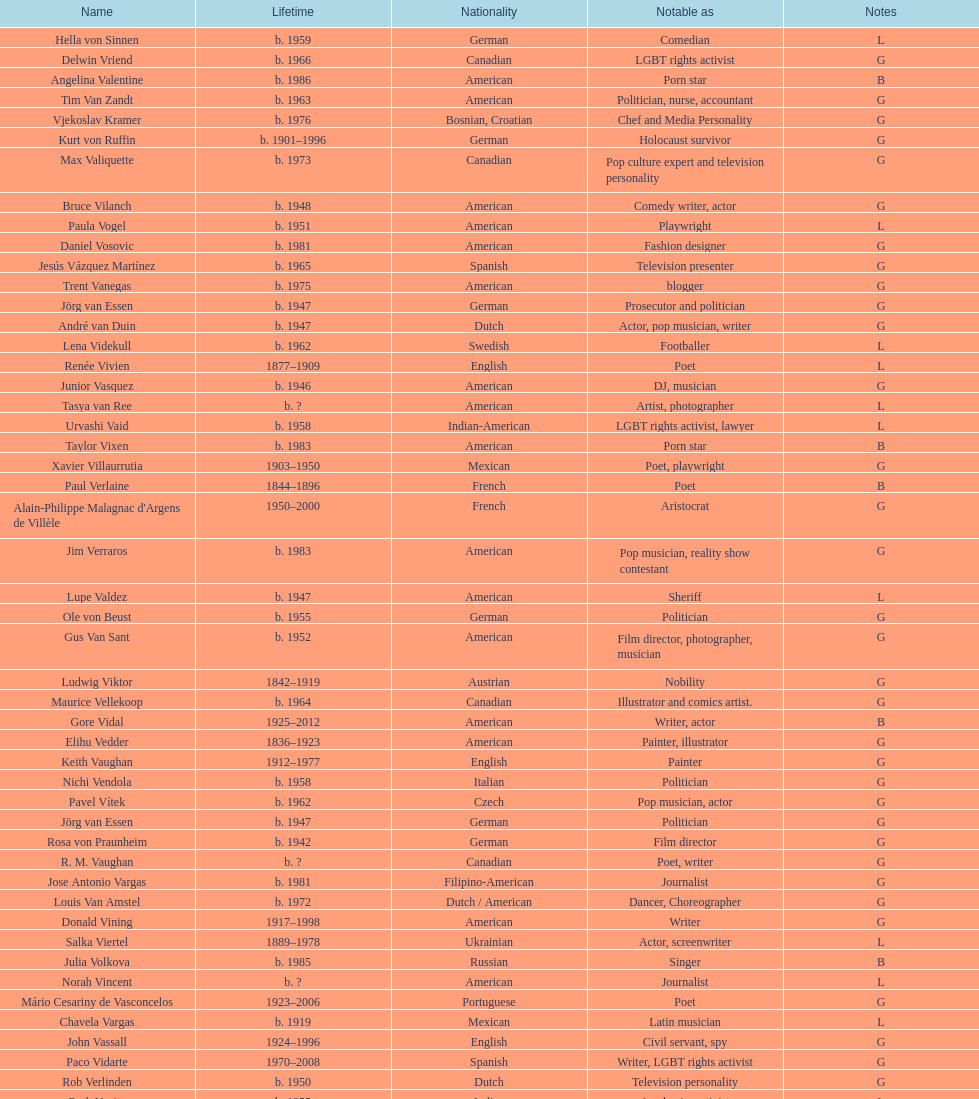Help me parse the entirety of this table. {'header': ['Name', 'Lifetime', 'Nationality', 'Notable as', 'Notes'], 'rows': [['Hella von Sinnen', 'b. 1959', 'German', 'Comedian', 'L'], ['Delwin Vriend', 'b. 1966', 'Canadian', 'LGBT rights activist', 'G'], ['Angelina Valentine', 'b. 1986', 'American', 'Porn star', 'B'], ['Tim Van Zandt', 'b. 1963', 'American', 'Politician, nurse, accountant', 'G'], ['Vjekoslav Kramer', 'b. 1976', 'Bosnian, Croatian', 'Chef and Media Personality', 'G'], ['Kurt von Ruffin', 'b. 1901–1996', 'German', 'Holocaust survivor', 'G'], ['Max Valiquette', 'b. 1973', 'Canadian', 'Pop culture expert and television personality', 'G'], ['Bruce Vilanch', 'b. 1948', 'American', 'Comedy writer, actor', 'G'], ['Paula Vogel', 'b. 1951', 'American', 'Playwright', 'L'], ['Daniel Vosovic', 'b. 1981', 'American', 'Fashion designer', 'G'], ['Jesús Vázquez Martínez', 'b. 1965', 'Spanish', 'Television presenter', 'G'], ['Trent Vanegas', 'b. 1975', 'American', 'blogger', 'G'], ['Jörg van Essen', 'b. 1947', 'German', 'Prosecutor and politician', 'G'], ['André van Duin', 'b. 1947', 'Dutch', 'Actor, pop musician, writer', 'G'], ['Lena Videkull', 'b. 1962', 'Swedish', 'Footballer', 'L'], ['Renée Vivien', '1877–1909', 'English', 'Poet', 'L'], ['Junior Vasquez', 'b. 1946', 'American', 'DJ, musician', 'G'], ['Tasya van Ree', 'b.\xa0?', 'American', 'Artist, photographer', 'L'], ['Urvashi Vaid', 'b. 1958', 'Indian-American', 'LGBT rights activist, lawyer', 'L'], ['Taylor Vixen', 'b. 1983', 'American', 'Porn star', 'B'], ['Xavier Villaurrutia', '1903–1950', 'Mexican', 'Poet, playwright', 'G'], ['Paul Verlaine', '1844–1896', 'French', 'Poet', 'B'], ["Alain-Philippe Malagnac d'Argens de Villèle", '1950–2000', 'French', 'Aristocrat', 'G'], ['Jim Verraros', 'b. 1983', 'American', 'Pop musician, reality show contestant', 'G'], ['Lupe Valdez', 'b. 1947', 'American', 'Sheriff', 'L'], ['Ole von Beust', 'b. 1955', 'German', 'Politician', 'G'], ['Gus Van Sant', 'b. 1952', 'American', 'Film director, photographer, musician', 'G'], ['Ludwig Viktor', '1842–1919', 'Austrian', 'Nobility', 'G'], ['Maurice Vellekoop', 'b. 1964', 'Canadian', 'Illustrator and comics artist.', 'G'], ['Gore Vidal', '1925–2012', 'American', 'Writer, actor', 'B'], ['Elihu Vedder', '1836–1923', 'American', 'Painter, illustrator', 'G'], ['Keith Vaughan', '1912–1977', 'English', 'Painter', 'G'], ['Nichi Vendola', 'b. 1958', 'Italian', 'Politician', 'G'], ['Pavel Vítek', 'b. 1962', 'Czech', 'Pop musician, actor', 'G'], ['Jörg van Essen', 'b. 1947', 'German', 'Politician', 'G'], ['Rosa von Praunheim', 'b. 1942', 'German', 'Film director', 'G'], ['R. M. Vaughan', 'b.\xa0?', 'Canadian', 'Poet, writer', 'G'], ['Jose Antonio Vargas', 'b. 1981', 'Filipino-American', 'Journalist', 'G'], ['Louis Van Amstel', 'b. 1972', 'Dutch / American', 'Dancer, Choreographer', 'G'], ['Donald Vining', '1917–1998', 'American', 'Writer', 'G'], ['Salka Viertel', '1889–1978', 'Ukrainian', 'Actor, screenwriter', 'L'], ['Julia Volkova', 'b. 1985', 'Russian', 'Singer', 'B'], ['Norah Vincent', 'b.\xa0?', 'American', 'Journalist', 'L'], ['Mário Cesariny de Vasconcelos', '1923–2006', 'Portuguese', 'Poet', 'G'], ['Chavela Vargas', 'b. 1919', 'Mexican', 'Latin musician', 'L'], ['John Vassall', '1924–1996', 'English', 'Civil servant, spy', 'G'], ['Paco Vidarte', '1970–2008', 'Spanish', 'Writer, LGBT rights activist', 'G'], ['Rob Verlinden', 'b. 1950', 'Dutch', 'Television personality', 'G'], ['Ruth Vanita', 'b. 1955', 'Indian', 'Academic, activist', 'L'], ['Claude Vivier', '1948–1983', 'Canadian', '20th century classical composer', 'G'], ['Arthur H. Vandenberg, Jr.', 'b. 1907', 'American', 'government official, politician', 'G'], ['António Variações', '1944–1984', 'Portuguese', 'Pop musician', 'G'], ['Gianni Versace', '1946–1997', 'Italian', 'Fashion designer', 'G'], ['Wilhelm von Gloeden', '1856–1931', 'German', 'Photographer', 'G'], ['Théophile de Viau', '1590–1626', 'French', 'Poet, dramatist', 'G'], ['Jennifer Veiga', 'b. 1962', 'American', 'Politician', 'L'], ['Ron Vawter', '1948–1994', 'American', 'Actor', 'G'], ['Bruce Voeller', '1934–1994', 'American', 'HIV/AIDS researcher', 'G'], ['Börje Vestlund', 'b. 1960', 'Swedish', 'Politician', 'G'], ['Luchino Visconti', '1906–1976', 'Italian', 'Filmmaker', 'G'], ['Reg Vermue', 'b.\xa0?', 'Canadian', 'Rock musician', 'G'], ['Werner Veigel', '1928–1995', 'German', 'News presenter', 'G'], ['Anthony Venn-Brown', 'b. 1951', 'Australian', 'Author, former evangelist', 'G'], ['Carmen Vázquez', 'b.\xa0?', 'Cuban-American', 'Activist, writer', 'L'], ['Carl Van Vechten', '1880–1964', 'American', 'Writer, photographer', 'G'], ['Patricia Velásquez', 'b. 1971', 'Venezuelan', 'Actor, model', 'B'], ['Tom Villard', '1953–1994', 'American', 'Actor', 'G'], ['Christine Vachon', 'b. 1962', 'American', 'Film producer', 'L'], ['Gerda Verburg', 'b. 1957', 'Dutch', 'Politician', 'L'], ['Gianni Vattimo', 'b. 1936', 'Italian', 'Writer, philosopher', 'G'], ['José Villarrubia', 'b. 1961', 'American', 'Artist', 'G'], ['Nick Verreos', 'b. 1967', 'American', 'Fashion designer', 'G'], ['Pierre Vallières', '1938–1998', 'Québécois', 'Journalist, writer', 'G']]} What was lupe valdez's former name? Urvashi Vaid. 